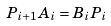<formula> <loc_0><loc_0><loc_500><loc_500>P _ { i + 1 } A _ { i } = B _ { i } P _ { i }</formula> 